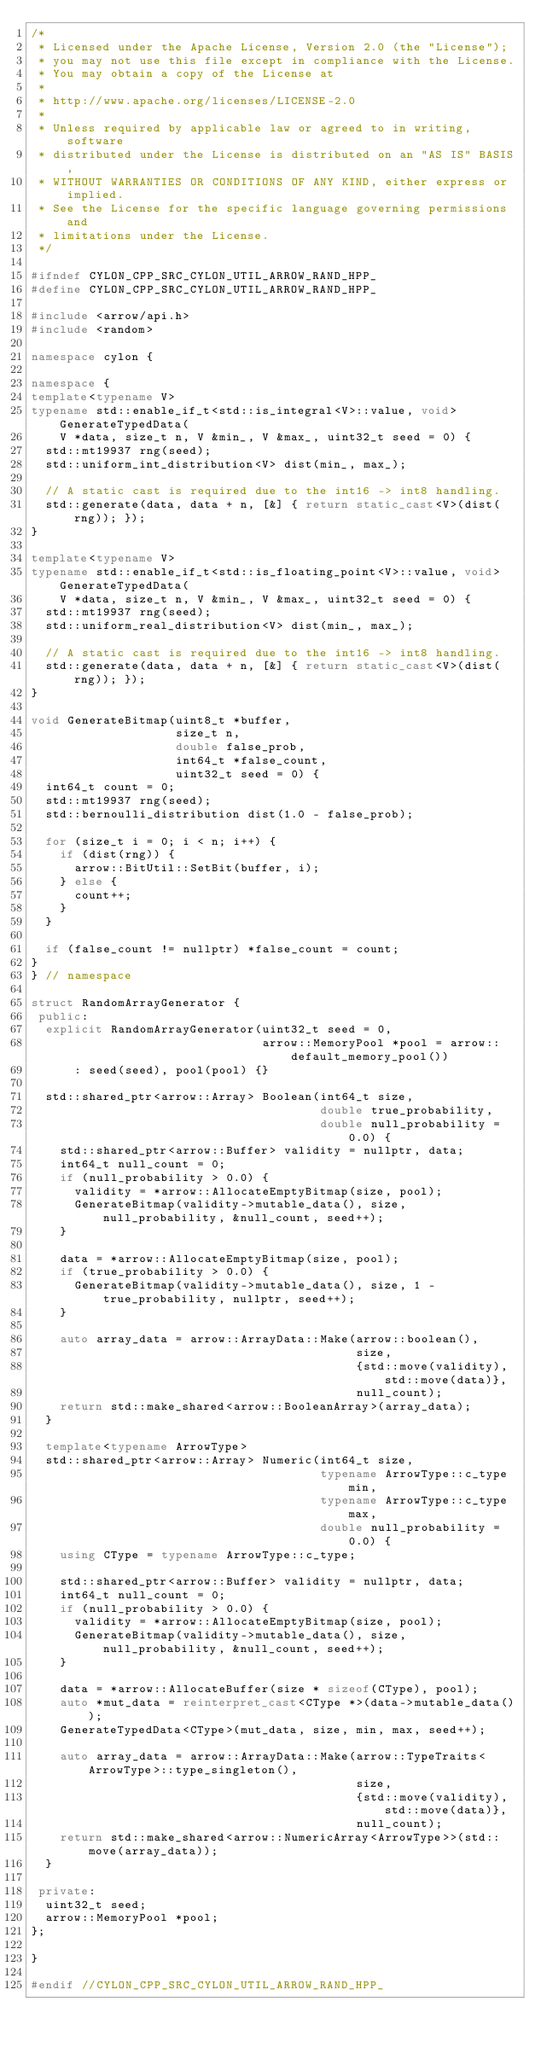Convert code to text. <code><loc_0><loc_0><loc_500><loc_500><_C++_>/*
 * Licensed under the Apache License, Version 2.0 (the "License");
 * you may not use this file except in compliance with the License.
 * You may obtain a copy of the License at
 *
 * http://www.apache.org/licenses/LICENSE-2.0
 *
 * Unless required by applicable law or agreed to in writing, software
 * distributed under the License is distributed on an "AS IS" BASIS,
 * WITHOUT WARRANTIES OR CONDITIONS OF ANY KIND, either express or implied.
 * See the License for the specific language governing permissions and
 * limitations under the License.
 */

#ifndef CYLON_CPP_SRC_CYLON_UTIL_ARROW_RAND_HPP_
#define CYLON_CPP_SRC_CYLON_UTIL_ARROW_RAND_HPP_

#include <arrow/api.h>
#include <random>

namespace cylon {

namespace {
template<typename V>
typename std::enable_if_t<std::is_integral<V>::value, void> GenerateTypedData(
    V *data, size_t n, V &min_, V &max_, uint32_t seed = 0) {
  std::mt19937 rng(seed);
  std::uniform_int_distribution<V> dist(min_, max_);

  // A static cast is required due to the int16 -> int8 handling.
  std::generate(data, data + n, [&] { return static_cast<V>(dist(rng)); });
}

template<typename V>
typename std::enable_if_t<std::is_floating_point<V>::value, void> GenerateTypedData(
    V *data, size_t n, V &min_, V &max_, uint32_t seed = 0) {
  std::mt19937 rng(seed);
  std::uniform_real_distribution<V> dist(min_, max_);

  // A static cast is required due to the int16 -> int8 handling.
  std::generate(data, data + n, [&] { return static_cast<V>(dist(rng)); });
}

void GenerateBitmap(uint8_t *buffer,
                    size_t n,
                    double false_prob,
                    int64_t *false_count,
                    uint32_t seed = 0) {
  int64_t count = 0;
  std::mt19937 rng(seed);
  std::bernoulli_distribution dist(1.0 - false_prob);

  for (size_t i = 0; i < n; i++) {
    if (dist(rng)) {
      arrow::BitUtil::SetBit(buffer, i);
    } else {
      count++;
    }
  }

  if (false_count != nullptr) *false_count = count;
}
} // namespace

struct RandomArrayGenerator {
 public:
  explicit RandomArrayGenerator(uint32_t seed = 0,
                                arrow::MemoryPool *pool = arrow::default_memory_pool())
      : seed(seed), pool(pool) {}

  std::shared_ptr<arrow::Array> Boolean(int64_t size,
                                        double true_probability,
                                        double null_probability = 0.0) {
    std::shared_ptr<arrow::Buffer> validity = nullptr, data;
    int64_t null_count = 0;
    if (null_probability > 0.0) {
      validity = *arrow::AllocateEmptyBitmap(size, pool);
      GenerateBitmap(validity->mutable_data(), size, null_probability, &null_count, seed++);
    }

    data = *arrow::AllocateEmptyBitmap(size, pool);
    if (true_probability > 0.0) {
      GenerateBitmap(validity->mutable_data(), size, 1 - true_probability, nullptr, seed++);
    }

    auto array_data = arrow::ArrayData::Make(arrow::boolean(),
                                             size,
                                             {std::move(validity), std::move(data)},
                                             null_count);
    return std::make_shared<arrow::BooleanArray>(array_data);
  }

  template<typename ArrowType>
  std::shared_ptr<arrow::Array> Numeric(int64_t size,
                                        typename ArrowType::c_type min,
                                        typename ArrowType::c_type max,
                                        double null_probability = 0.0) {
    using CType = typename ArrowType::c_type;

    std::shared_ptr<arrow::Buffer> validity = nullptr, data;
    int64_t null_count = 0;
    if (null_probability > 0.0) {
      validity = *arrow::AllocateEmptyBitmap(size, pool);
      GenerateBitmap(validity->mutable_data(), size, null_probability, &null_count, seed++);
    }

    data = *arrow::AllocateBuffer(size * sizeof(CType), pool);
    auto *mut_data = reinterpret_cast<CType *>(data->mutable_data());
    GenerateTypedData<CType>(mut_data, size, min, max, seed++);

    auto array_data = arrow::ArrayData::Make(arrow::TypeTraits<ArrowType>::type_singleton(),
                                             size,
                                             {std::move(validity), std::move(data)},
                                             null_count);
    return std::make_shared<arrow::NumericArray<ArrowType>>(std::move(array_data));
  }

 private:
  uint32_t seed;
  arrow::MemoryPool *pool;
};

}

#endif //CYLON_CPP_SRC_CYLON_UTIL_ARROW_RAND_HPP_
</code> 